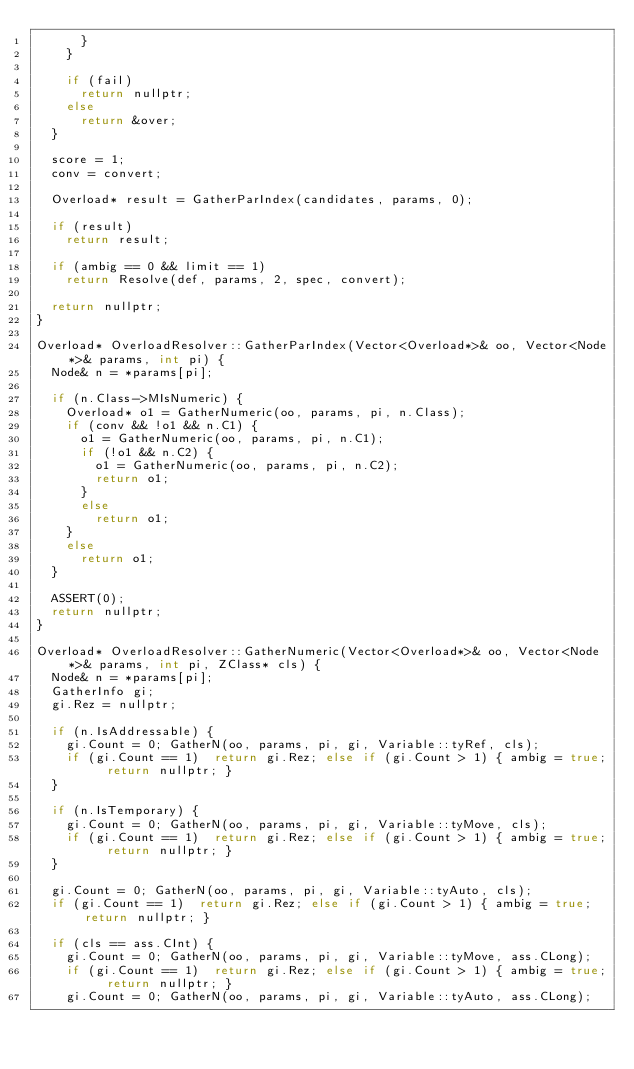<code> <loc_0><loc_0><loc_500><loc_500><_C++_>			}
		}
		
		if (fail)
			return nullptr;
		else
			return &over;
	}
	
	score = 1;
	conv = convert;
		
	Overload* result = GatherParIndex(candidates, params, 0);
	
	if (result)
		return result;
	
	if (ambig == 0 && limit == 1)
		return Resolve(def, params, 2, spec, convert);
	
	return nullptr;
}

Overload* OverloadResolver::GatherParIndex(Vector<Overload*>& oo, Vector<Node*>& params, int pi) {
	Node& n = *params[pi];
	
	if (n.Class->MIsNumeric) {
		Overload* o1 = GatherNumeric(oo, params, pi, n.Class);
		if (conv && !o1 && n.C1) {
			o1 = GatherNumeric(oo, params, pi, n.C1);
			if (!o1 && n.C2) {
				o1 = GatherNumeric(oo, params, pi, n.C2);
				return o1;
			}
			else
				return o1;
		}
		else
			return o1;
	}
	
	ASSERT(0);
	return nullptr;
}

Overload* OverloadResolver::GatherNumeric(Vector<Overload*>& oo, Vector<Node*>& params, int pi, ZClass* cls) {
	Node& n = *params[pi];
	GatherInfo gi;
	gi.Rez = nullptr;
	
	if (n.IsAddressable) {
		gi.Count = 0; GatherN(oo, params, pi, gi, Variable::tyRef, cls);
		if (gi.Count == 1)	return gi.Rez; else if (gi.Count > 1) { ambig = true; return nullptr; }
	}
	
	if (n.IsTemporary) {
		gi.Count = 0; GatherN(oo, params, pi, gi, Variable::tyMove, cls);
		if (gi.Count == 1)	return gi.Rez; else if (gi.Count > 1) { ambig = true; return nullptr; }
	}
	
	gi.Count = 0; GatherN(oo, params, pi, gi, Variable::tyAuto, cls);
	if (gi.Count == 1)	return gi.Rez; else if (gi.Count > 1) { ambig = true; return nullptr; }
			
	if (cls == ass.CInt) {
		gi.Count = 0; GatherN(oo, params, pi, gi, Variable::tyMove, ass.CLong);
		if (gi.Count == 1)	return gi.Rez; else if (gi.Count > 1) { ambig = true; return nullptr; }
		gi.Count = 0; GatherN(oo, params, pi, gi, Variable::tyAuto, ass.CLong);</code> 